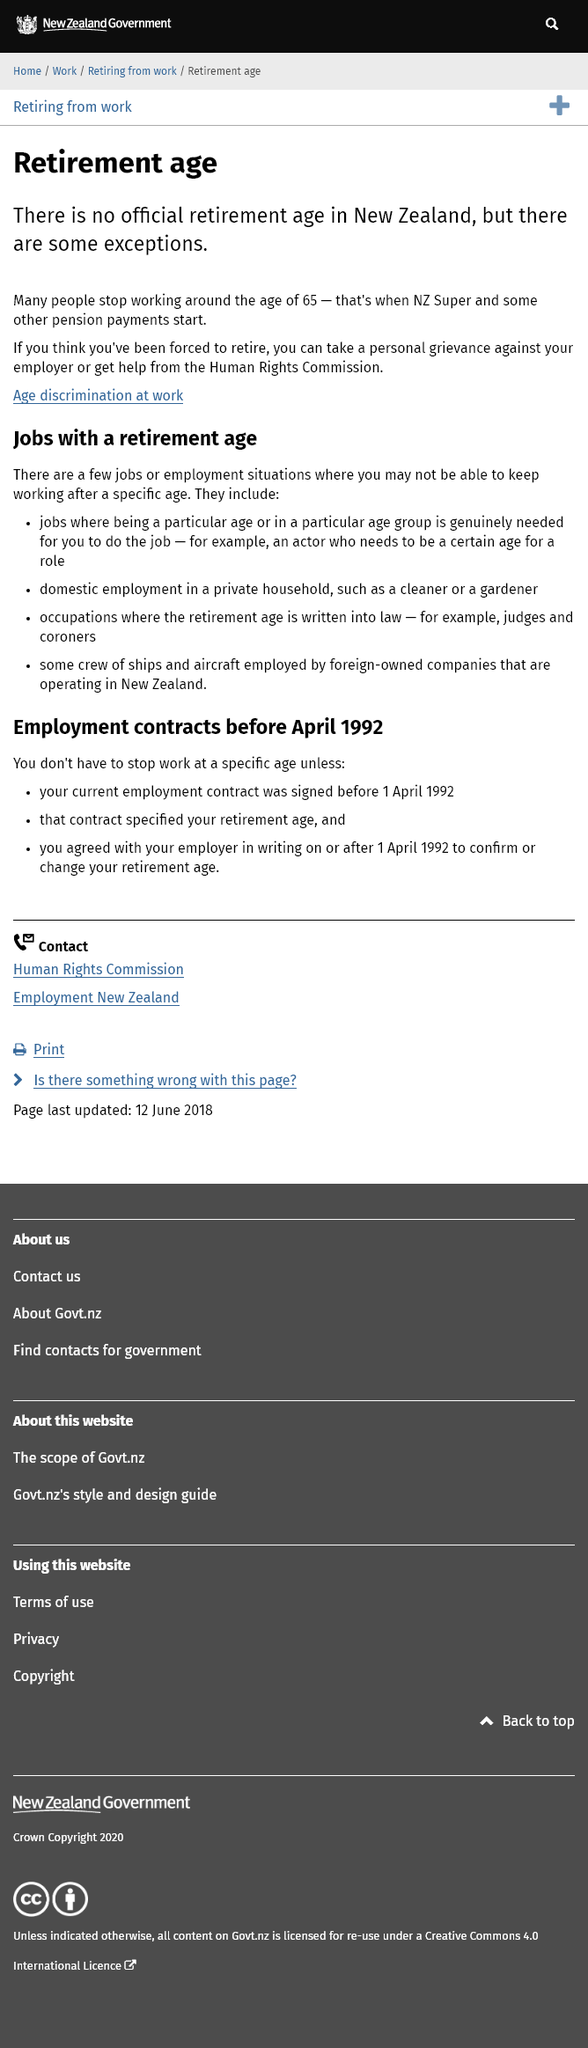Draw attention to some important aspects in this diagram. In New Zealand, there is no official retirement age. Many people retire around the age of 65. The Human Rights Commission can assist individuals who have been compelled to retire and require support. 